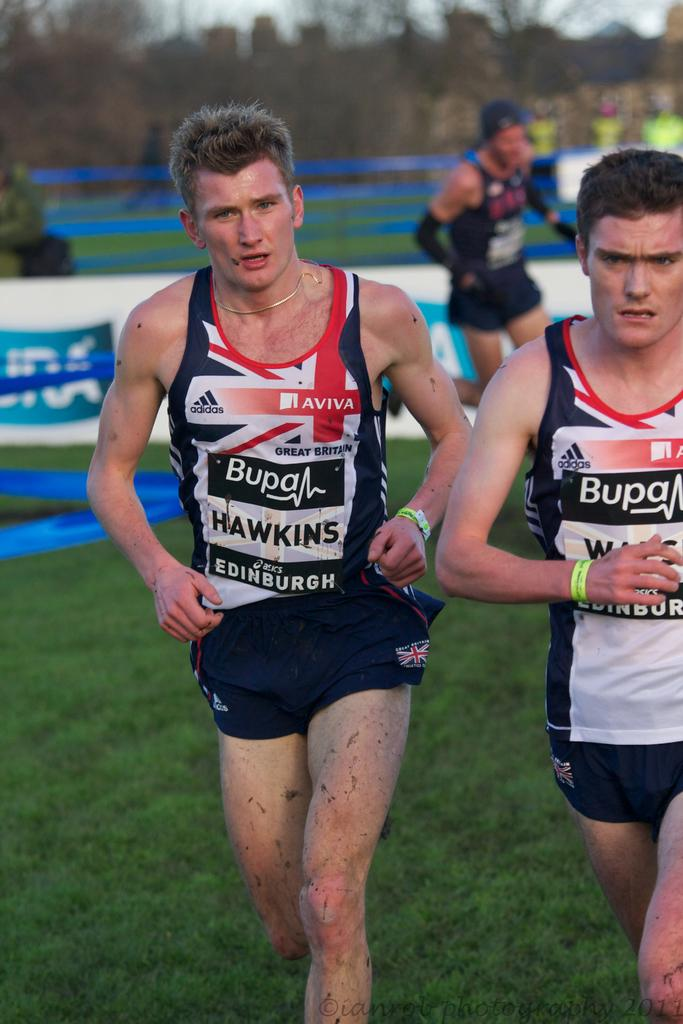<image>
Present a compact description of the photo's key features. a man that has the word Hawkins on his outfit 